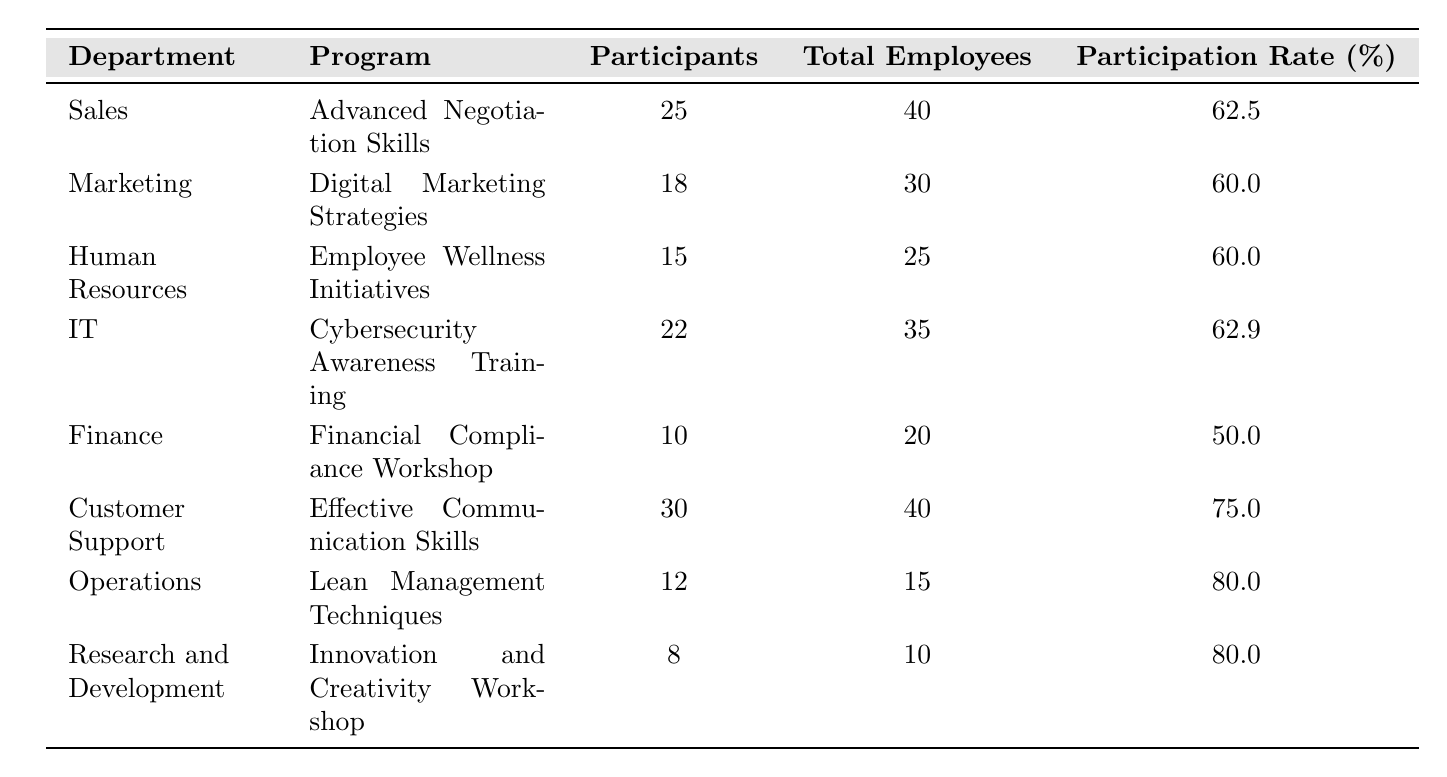What is the participation rate for the Sales department? The table shows that the participation rate for the Sales department is listed as 62.5%.
Answer: 62.5% Which training program has the highest participation rate? By examining the participation rates in the table, Operations and Research and Development both have the highest participation rate of 80.0%.
Answer: 80.0% How many total employees participated in the training programs for the IT and Finance departments combined? Looking at the table, the IT department had 22 participants and the Finance department had 10 participants. Adding these together gives 22 + 10 = 32 participants.
Answer: 32 Is the participation rate for Marketing higher than that for Human Resources? The participation rate for Marketing is 60.0% and for Human Resources is also 60.0%. Therefore, the participation rates are equal, so the answer is no.
Answer: No What is the average participation rate across all listed departments? The participation rates are 62.5, 60.0, 60.0, 62.9, 50.0, 75.0, 80.0, and 80.0. Adding these gives a total of 430.5 and there are 8 departments, so the average is 430.5 / 8 = 53.8125.
Answer: 53.8125 What percentage of employees in the Operations department participated in the training program? The Operations department had 12 participants out of a total of 15 employees. The participation rate is calculated as (12/15) * 100 = 80.0%.
Answer: 80.0% How many more participants were there in the Customer Support training program compared to the Finance training program? The Customer Support program had 30 participants while the Finance program had 10 participants. The difference is calculated as 30 - 10 = 20.
Answer: 20 Do all departments have a participation rate of at least 50%? The Finance department has a participation rate of 50.0%, while all other departments have higher rates, confirming that all departments meet the minimum of 50%.
Answer: Yes What is the total number of employees across all departments listed? By adding the total employees from each department: 40 + 30 + 25 + 35 + 20 + 40 + 15 + 10 = 305.
Answer: 305 How does the participation rate of the IT department compare to that of the Sales department? The IT department has a participation rate of 62.9%, while the Sales department has a participation rate of 62.5%. Thus, IT has a higher participation rate than Sales.
Answer: IT's rate is higher Which department had fewer participants than employees in their training programs? By checking the table, Finance had 10 participants but 20 employees, which is fewer than the total number.
Answer: Finance department 